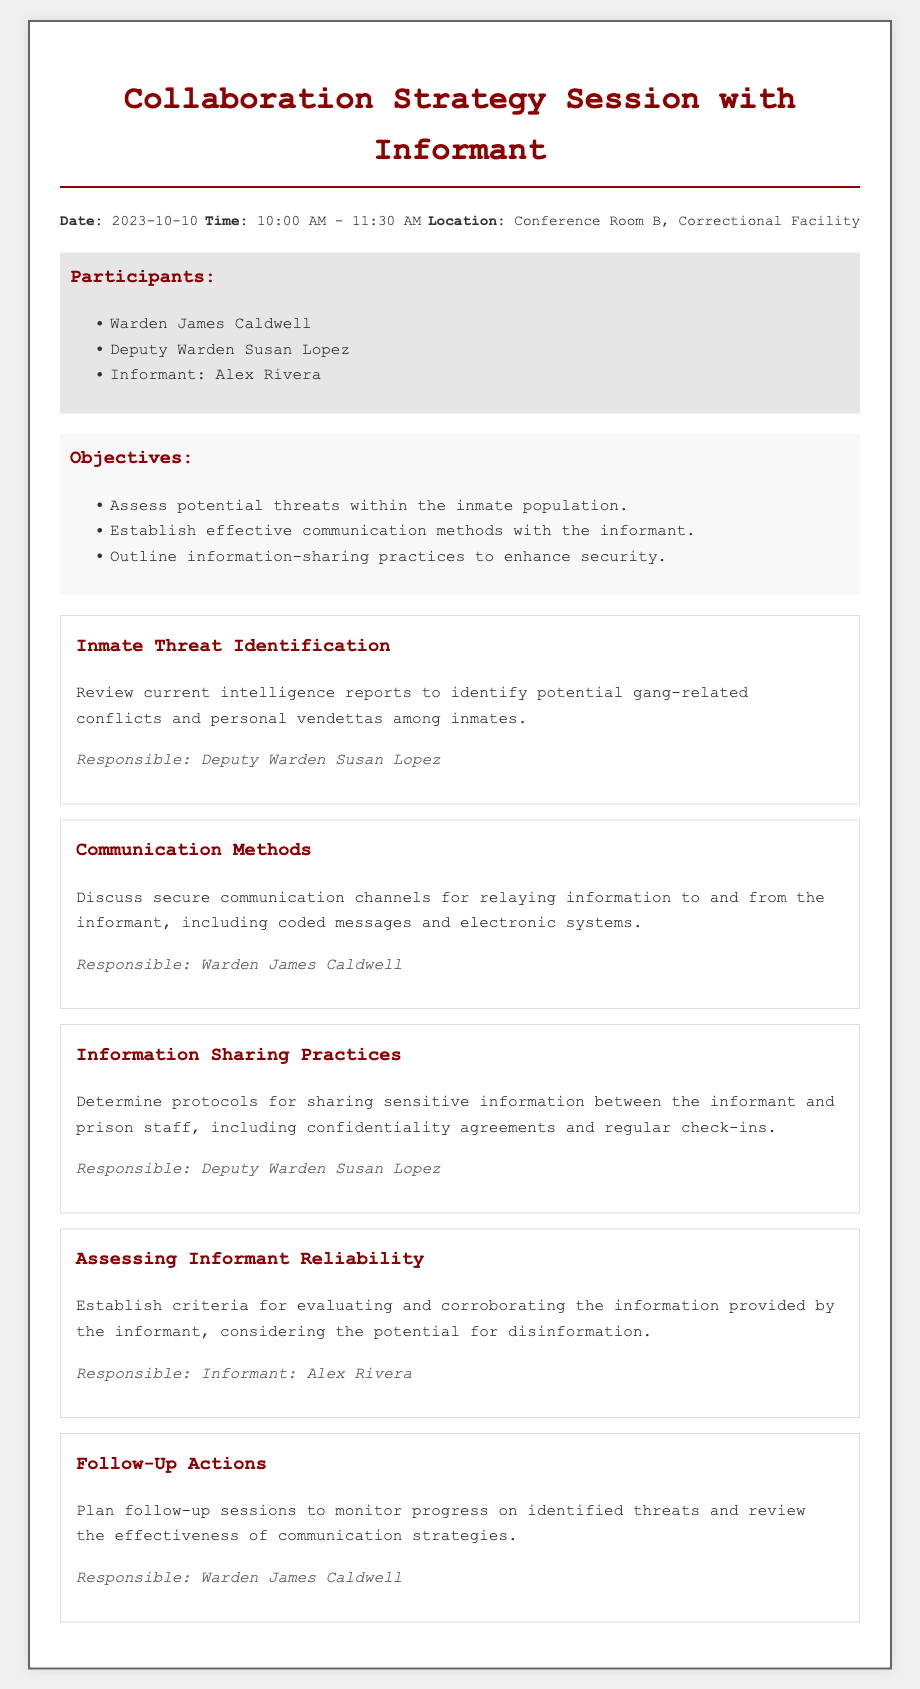What is the date of the session? The date of the session is specifically mentioned in the header information of the document.
Answer: 2023-10-10 Who is responsible for assessing potential threats within the inmate population? The responsible participant for this task is noted in the relevant topic section of the document.
Answer: Deputy Warden Susan Lopez What communication methods are discussed? The topic on communication methods outlines the secure channels for relaying information.
Answer: Coded messages and electronic systems What criteria will be established for evaluating the informant's reliability? The document states that criteria will cover the corroboration of information and the potential for disinformation.
Answer: Criteria for evaluating and corroborating information What are the follow-up actions after the session? The follow-up actions are outlined in a specific topic within the document, detailing the plan for monitoring progress.
Answer: Plan follow-up sessions 